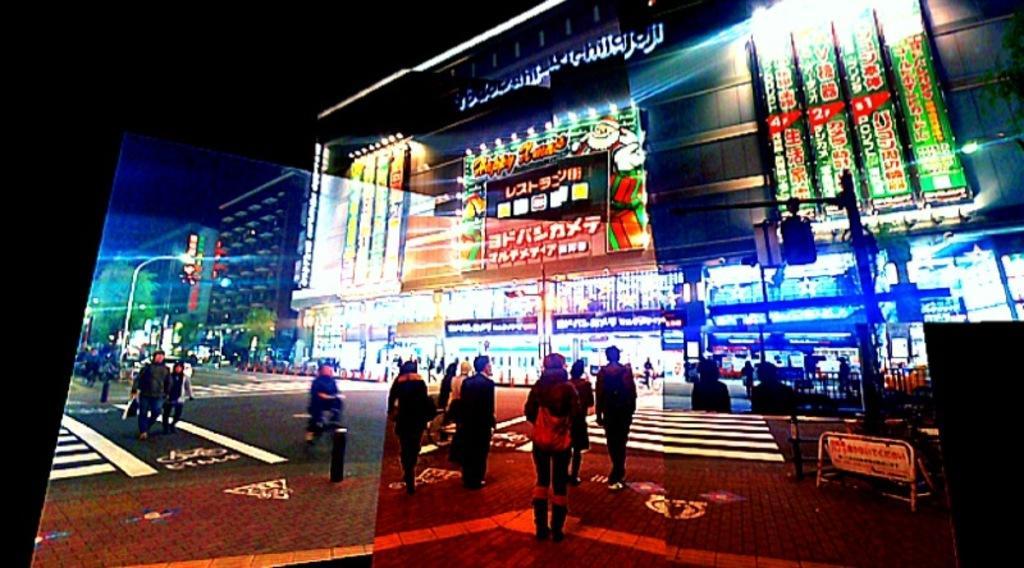Describe this image in one or two sentences. In this image on the road there are many people. In the background there are many buildings. Here there is tree. There are barricade. All these things are on a screen. 